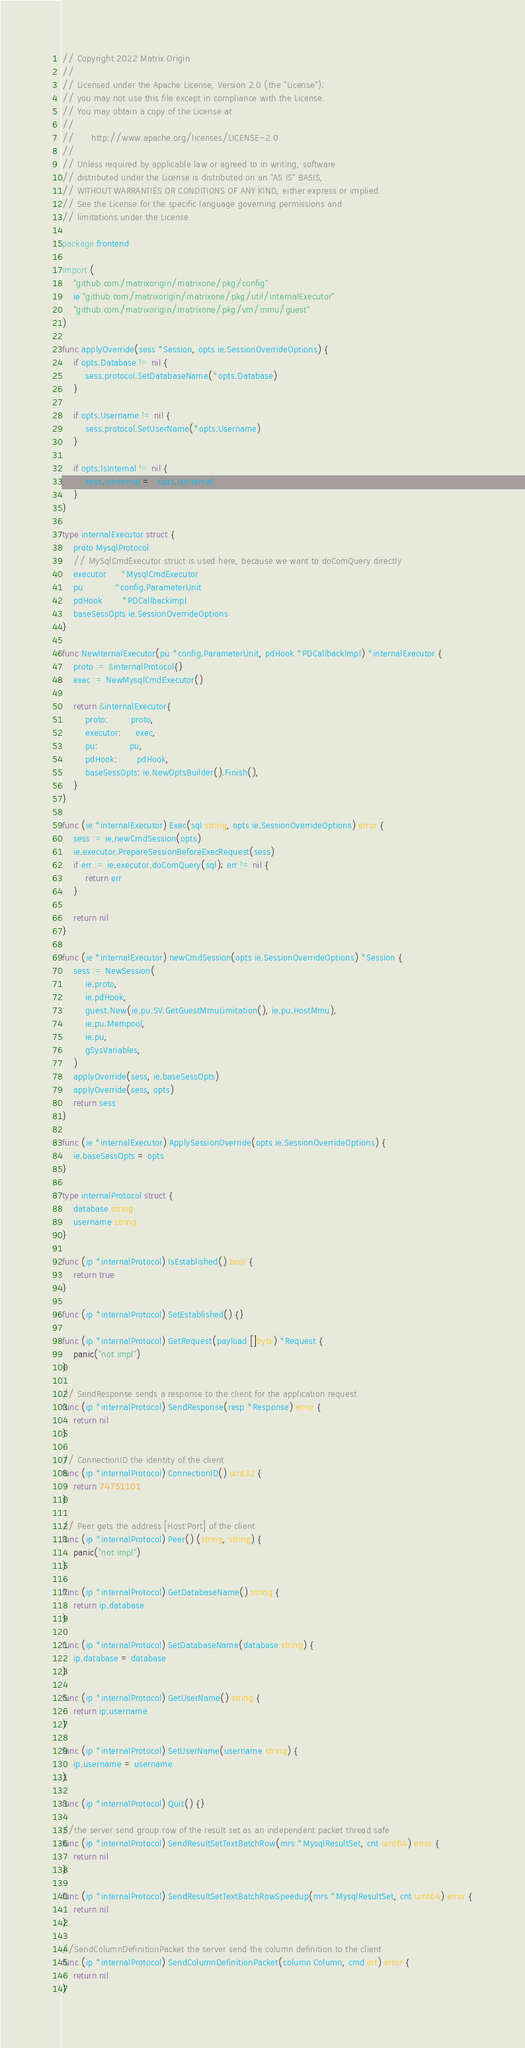<code> <loc_0><loc_0><loc_500><loc_500><_Go_>// Copyright 2022 Matrix Origin
//
// Licensed under the Apache License, Version 2.0 (the "License");
// you may not use this file except in compliance with the License.
// You may obtain a copy of the License at
//
//      http://www.apache.org/licenses/LICENSE-2.0
//
// Unless required by applicable law or agreed to in writing, software
// distributed under the License is distributed on an "AS IS" BASIS,
// WITHOUT WARRANTIES OR CONDITIONS OF ANY KIND, either express or implied.
// See the License for the specific language governing permissions and
// limitations under the License.

package frontend

import (
	"github.com/matrixorigin/matrixone/pkg/config"
	ie "github.com/matrixorigin/matrixone/pkg/util/internalExecutor"
	"github.com/matrixorigin/matrixone/pkg/vm/mmu/guest"
)

func applyOverride(sess *Session, opts ie.SessionOverrideOptions) {
	if opts.Database != nil {
		sess.protocol.SetDatabaseName(*opts.Database)
	}

	if opts.Username != nil {
		sess.protocol.SetUserName(*opts.Username)
	}

	if opts.IsInternal != nil {
		sess.IsInternal = *opts.IsInternal
	}
}

type internalExecutor struct {
	proto MysqlProtocol
	// MySqlCmdExecutor struct is used here, because we want to doComQuery directly
	executor     *MysqlCmdExecutor
	pu           *config.ParameterUnit
	pdHook       *PDCallbackImpl
	baseSessOpts ie.SessionOverrideOptions
}

func NewIternalExecutor(pu *config.ParameterUnit, pdHook *PDCallbackImpl) *internalExecutor {
	proto := &internalProtocol{}
	exec := NewMysqlCmdExecutor()

	return &internalExecutor{
		proto:        proto,
		executor:     exec,
		pu:           pu,
		pdHook:       pdHook,
		baseSessOpts: ie.NewOptsBuilder().Finish(),
	}
}

func (ie *internalExecutor) Exec(sql string, opts ie.SessionOverrideOptions) error {
	sess := ie.newCmdSession(opts)
	ie.executor.PrepareSessionBeforeExecRequest(sess)
	if err := ie.executor.doComQuery(sql); err != nil {
		return err
	}

	return nil
}

func (ie *internalExecutor) newCmdSession(opts ie.SessionOverrideOptions) *Session {
	sess := NewSession(
		ie.proto,
		ie.pdHook,
		guest.New(ie.pu.SV.GetGuestMmuLimitation(), ie.pu.HostMmu),
		ie.pu.Mempool,
		ie.pu,
		gSysVariables,
	)
	applyOverride(sess, ie.baseSessOpts)
	applyOverride(sess, opts)
	return sess
}

func (ie *internalExecutor) ApplySessionOverride(opts ie.SessionOverrideOptions) {
	ie.baseSessOpts = opts
}

type internalProtocol struct {
	database string
	username string
}

func (ip *internalProtocol) IsEstablished() bool {
	return true
}

func (ip *internalProtocol) SetEstablished() {}

func (ip *internalProtocol) GetRequest(payload []byte) *Request {
	panic("not impl")
}

// SendResponse sends a response to the client for the application request
func (ip *internalProtocol) SendResponse(resp *Response) error {
	return nil
}

// ConnectionID the identity of the client
func (ip *internalProtocol) ConnectionID() uint32 {
	return 74751101
}

// Peer gets the address [Host:Port] of the client
func (ip *internalProtocol) Peer() (string, string) {
	panic("not impl")
}

func (ip *internalProtocol) GetDatabaseName() string {
	return ip.database
}

func (ip *internalProtocol) SetDatabaseName(database string) {
	ip.database = database
}

func (ip *internalProtocol) GetUserName() string {
	return ip.username
}

func (ip *internalProtocol) SetUserName(username string) {
	ip.username = username
}

func (ip *internalProtocol) Quit() {}

//the server send group row of the result set as an independent packet thread safe
func (ip *internalProtocol) SendResultSetTextBatchRow(mrs *MysqlResultSet, cnt uint64) error {
	return nil
}

func (ip *internalProtocol) SendResultSetTextBatchRowSpeedup(mrs *MysqlResultSet, cnt uint64) error {
	return nil
}

//SendColumnDefinitionPacket the server send the column definition to the client
func (ip *internalProtocol) SendColumnDefinitionPacket(column Column, cmd int) error {
	return nil
}
</code> 